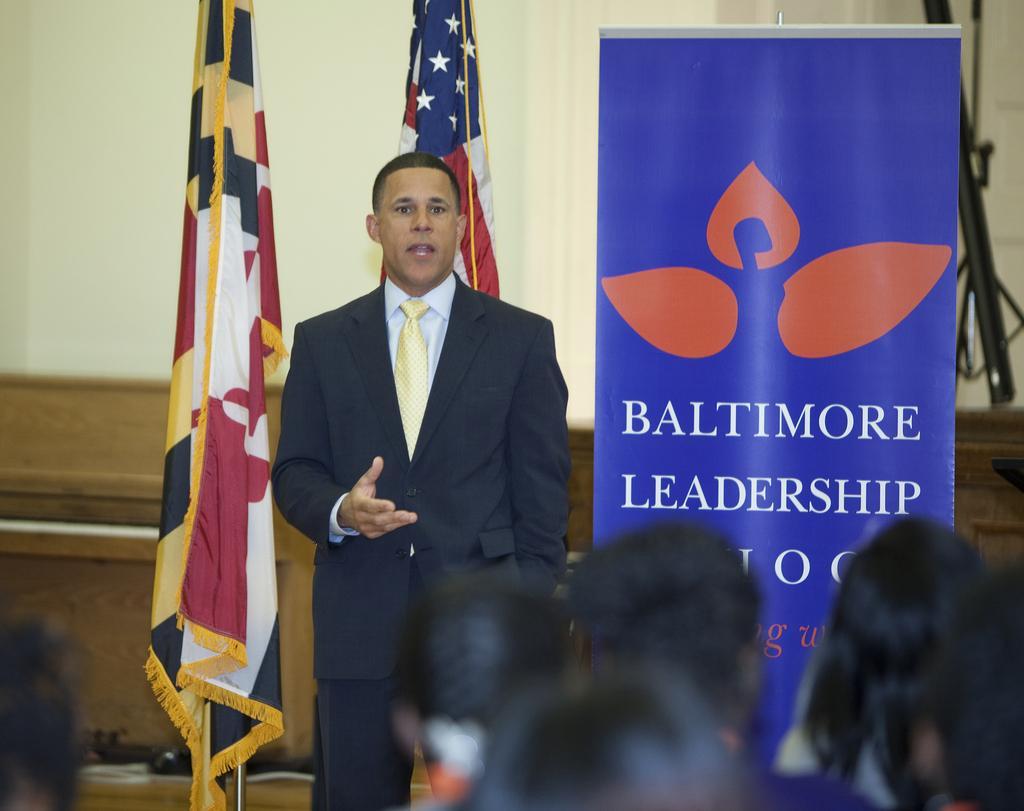Could you give a brief overview of what you see in this image? In this image there is a person standing on the stage. Behind him there are two flags. Beside the flag there is a board. In front of the person there are few people. At the back side there is a wall. 